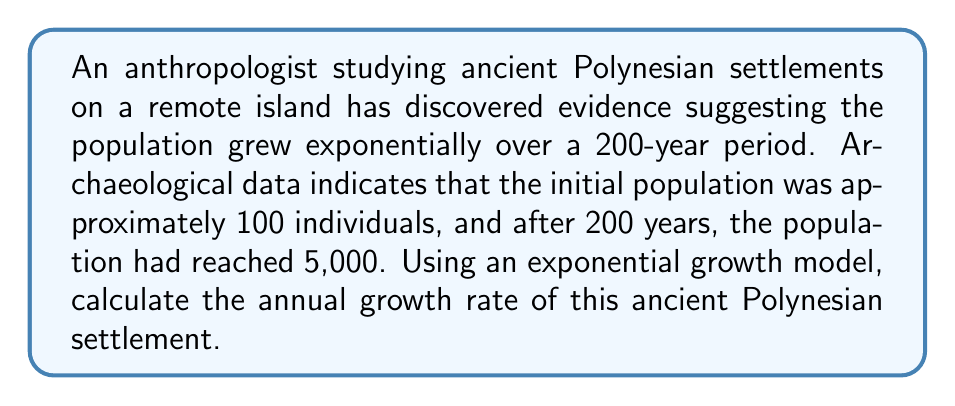Help me with this question. To solve this problem, we'll use the exponential growth formula:

$$P(t) = P_0 \cdot e^{rt}$$

Where:
$P(t)$ is the population at time $t$
$P_0$ is the initial population
$r$ is the growth rate
$t$ is the time period

Given:
$P_0 = 100$ (initial population)
$P(200) = 5000$ (population after 200 years)
$t = 200$ years

Step 1: Substitute the known values into the exponential growth formula:
$$5000 = 100 \cdot e^{200r}$$

Step 2: Divide both sides by 100:
$$50 = e^{200r}$$

Step 3: Take the natural logarithm of both sides:
$$\ln(50) = 200r$$

Step 4: Solve for $r$:
$$r = \frac{\ln(50)}{200}$$

Step 5: Calculate the value of $r$:
$$r = \frac{3.912023005}{200} = 0.01956011503$$

Step 6: Convert to a percentage:
$$r \approx 0.01956 \times 100\% = 1.956\%$$

Therefore, the annual growth rate of the ancient Polynesian settlement was approximately 1.956%.
Answer: 1.956% 